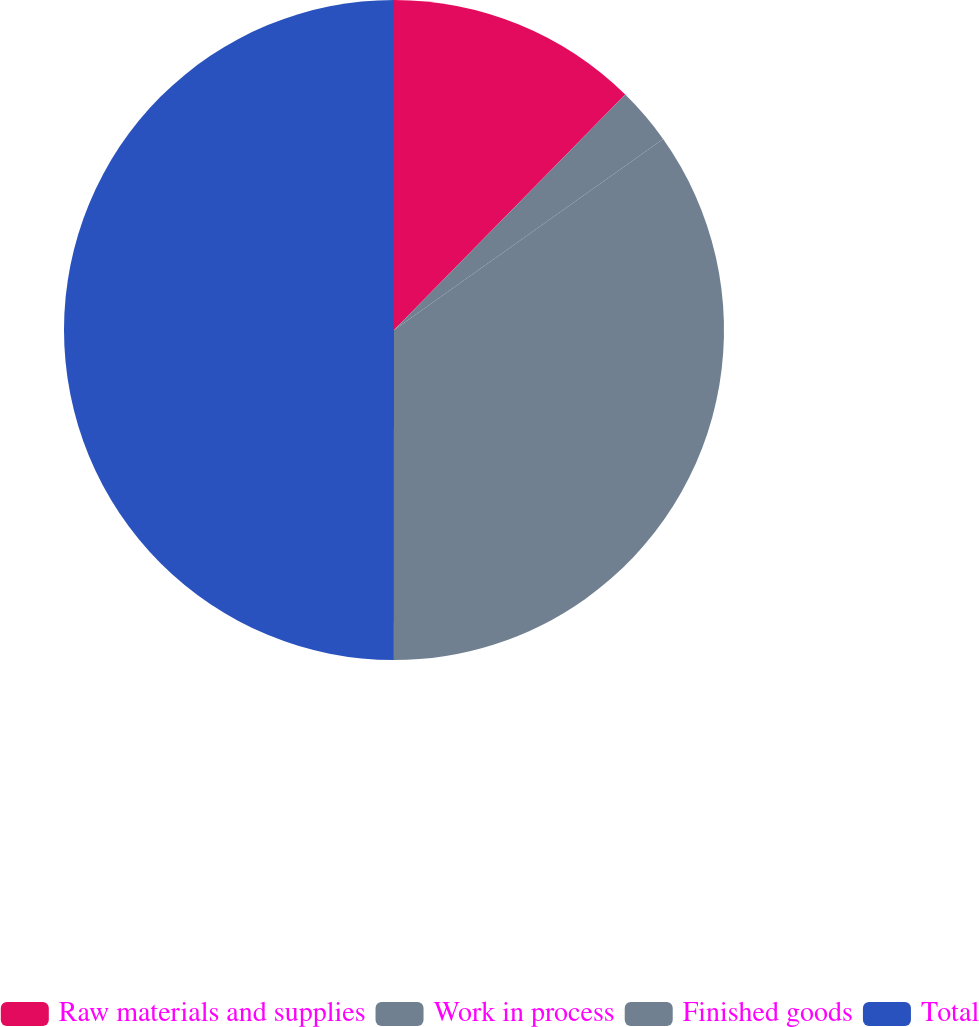<chart> <loc_0><loc_0><loc_500><loc_500><pie_chart><fcel>Raw materials and supplies<fcel>Work in process<fcel>Finished goods<fcel>Total<nl><fcel>12.36%<fcel>2.82%<fcel>34.83%<fcel>50.0%<nl></chart> 